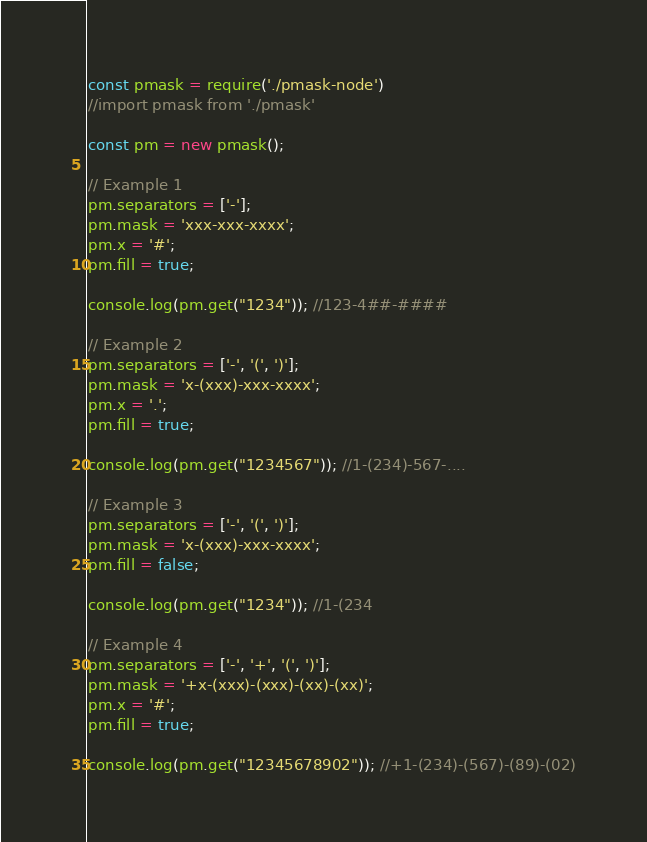Convert code to text. <code><loc_0><loc_0><loc_500><loc_500><_JavaScript_>const pmask = require('./pmask-node')
//import pmask from './pmask'

const pm = new pmask();

// Example 1
pm.separators = ['-'];
pm.mask = 'xxx-xxx-xxxx';
pm.x = '#';
pm.fill = true;

console.log(pm.get("1234")); //123-4##-####

// Example 2
pm.separators = ['-', '(', ')'];
pm.mask = 'x-(xxx)-xxx-xxxx';
pm.x = '.';
pm.fill = true;

console.log(pm.get("1234567")); //1-(234)-567-....

// Example 3
pm.separators = ['-', '(', ')'];
pm.mask = 'x-(xxx)-xxx-xxxx';
pm.fill = false;

console.log(pm.get("1234")); //1-(234

// Example 4
pm.separators = ['-', '+', '(', ')'];
pm.mask = '+x-(xxx)-(xxx)-(xx)-(xx)';
pm.x = '#';
pm.fill = true;

console.log(pm.get("12345678902")); //+1-(234)-(567)-(89)-(02)
</code> 